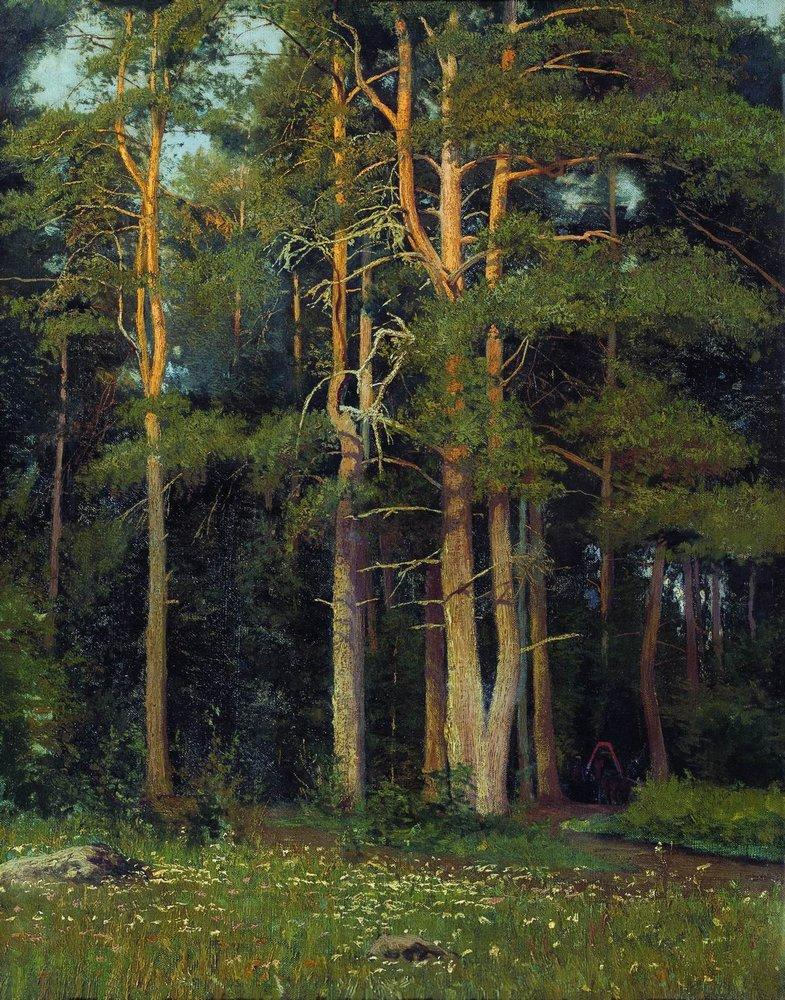What's the most unique thing about this forest? The most unique aspect of this forest is its timeless aura of tranquility. The artist's rendering captures not just the physical characteristics of the forest, but also an almost palpable sense of peace and stillness. The interplay of light and shadow, the meticulous detail in the foliage, and the inviting path leading into the depths of the forest all combine to create a scene that feels both intimate and infinitely expansive. This forest seems to hold a secret, perhaps the quiet wisdom of nature or the whispers of ancient trees, making it a truly enchanting and unique place. 